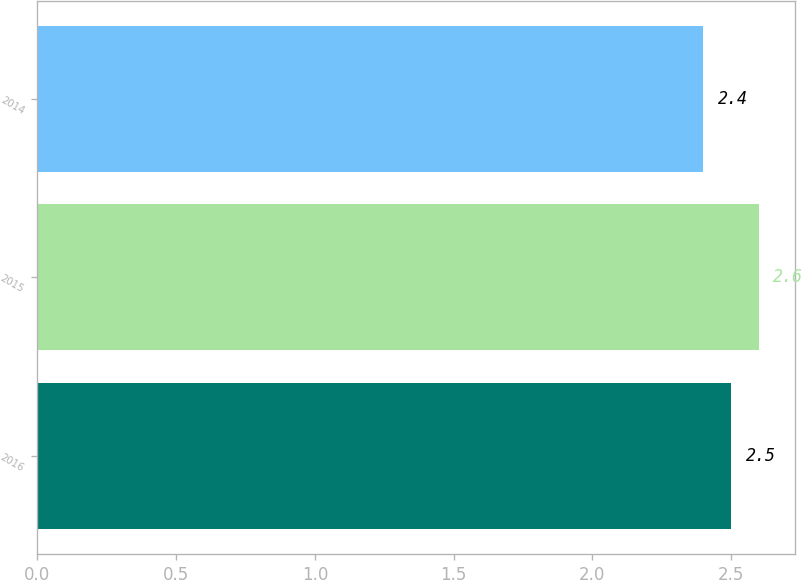<chart> <loc_0><loc_0><loc_500><loc_500><bar_chart><fcel>2016<fcel>2015<fcel>2014<nl><fcel>2.5<fcel>2.6<fcel>2.4<nl></chart> 